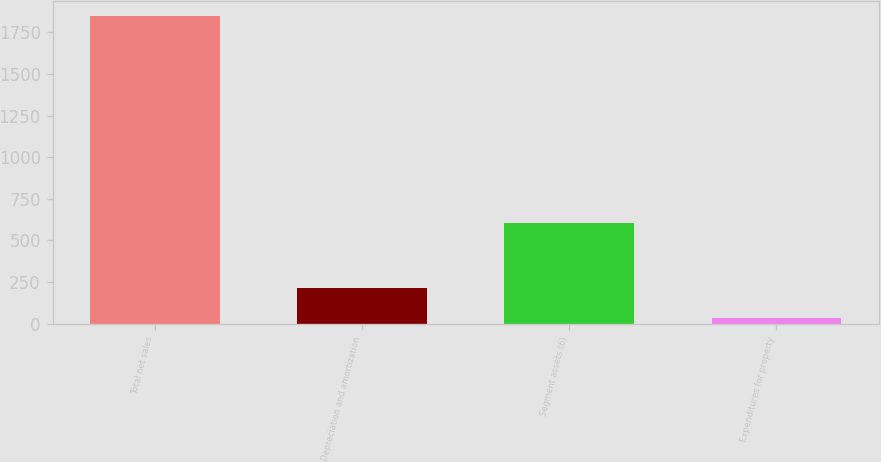Convert chart to OTSL. <chart><loc_0><loc_0><loc_500><loc_500><bar_chart><fcel>Total net sales<fcel>Depreciation and amortization<fcel>Segment assets (6)<fcel>Expenditures for property<nl><fcel>1845<fcel>216<fcel>603<fcel>35<nl></chart> 